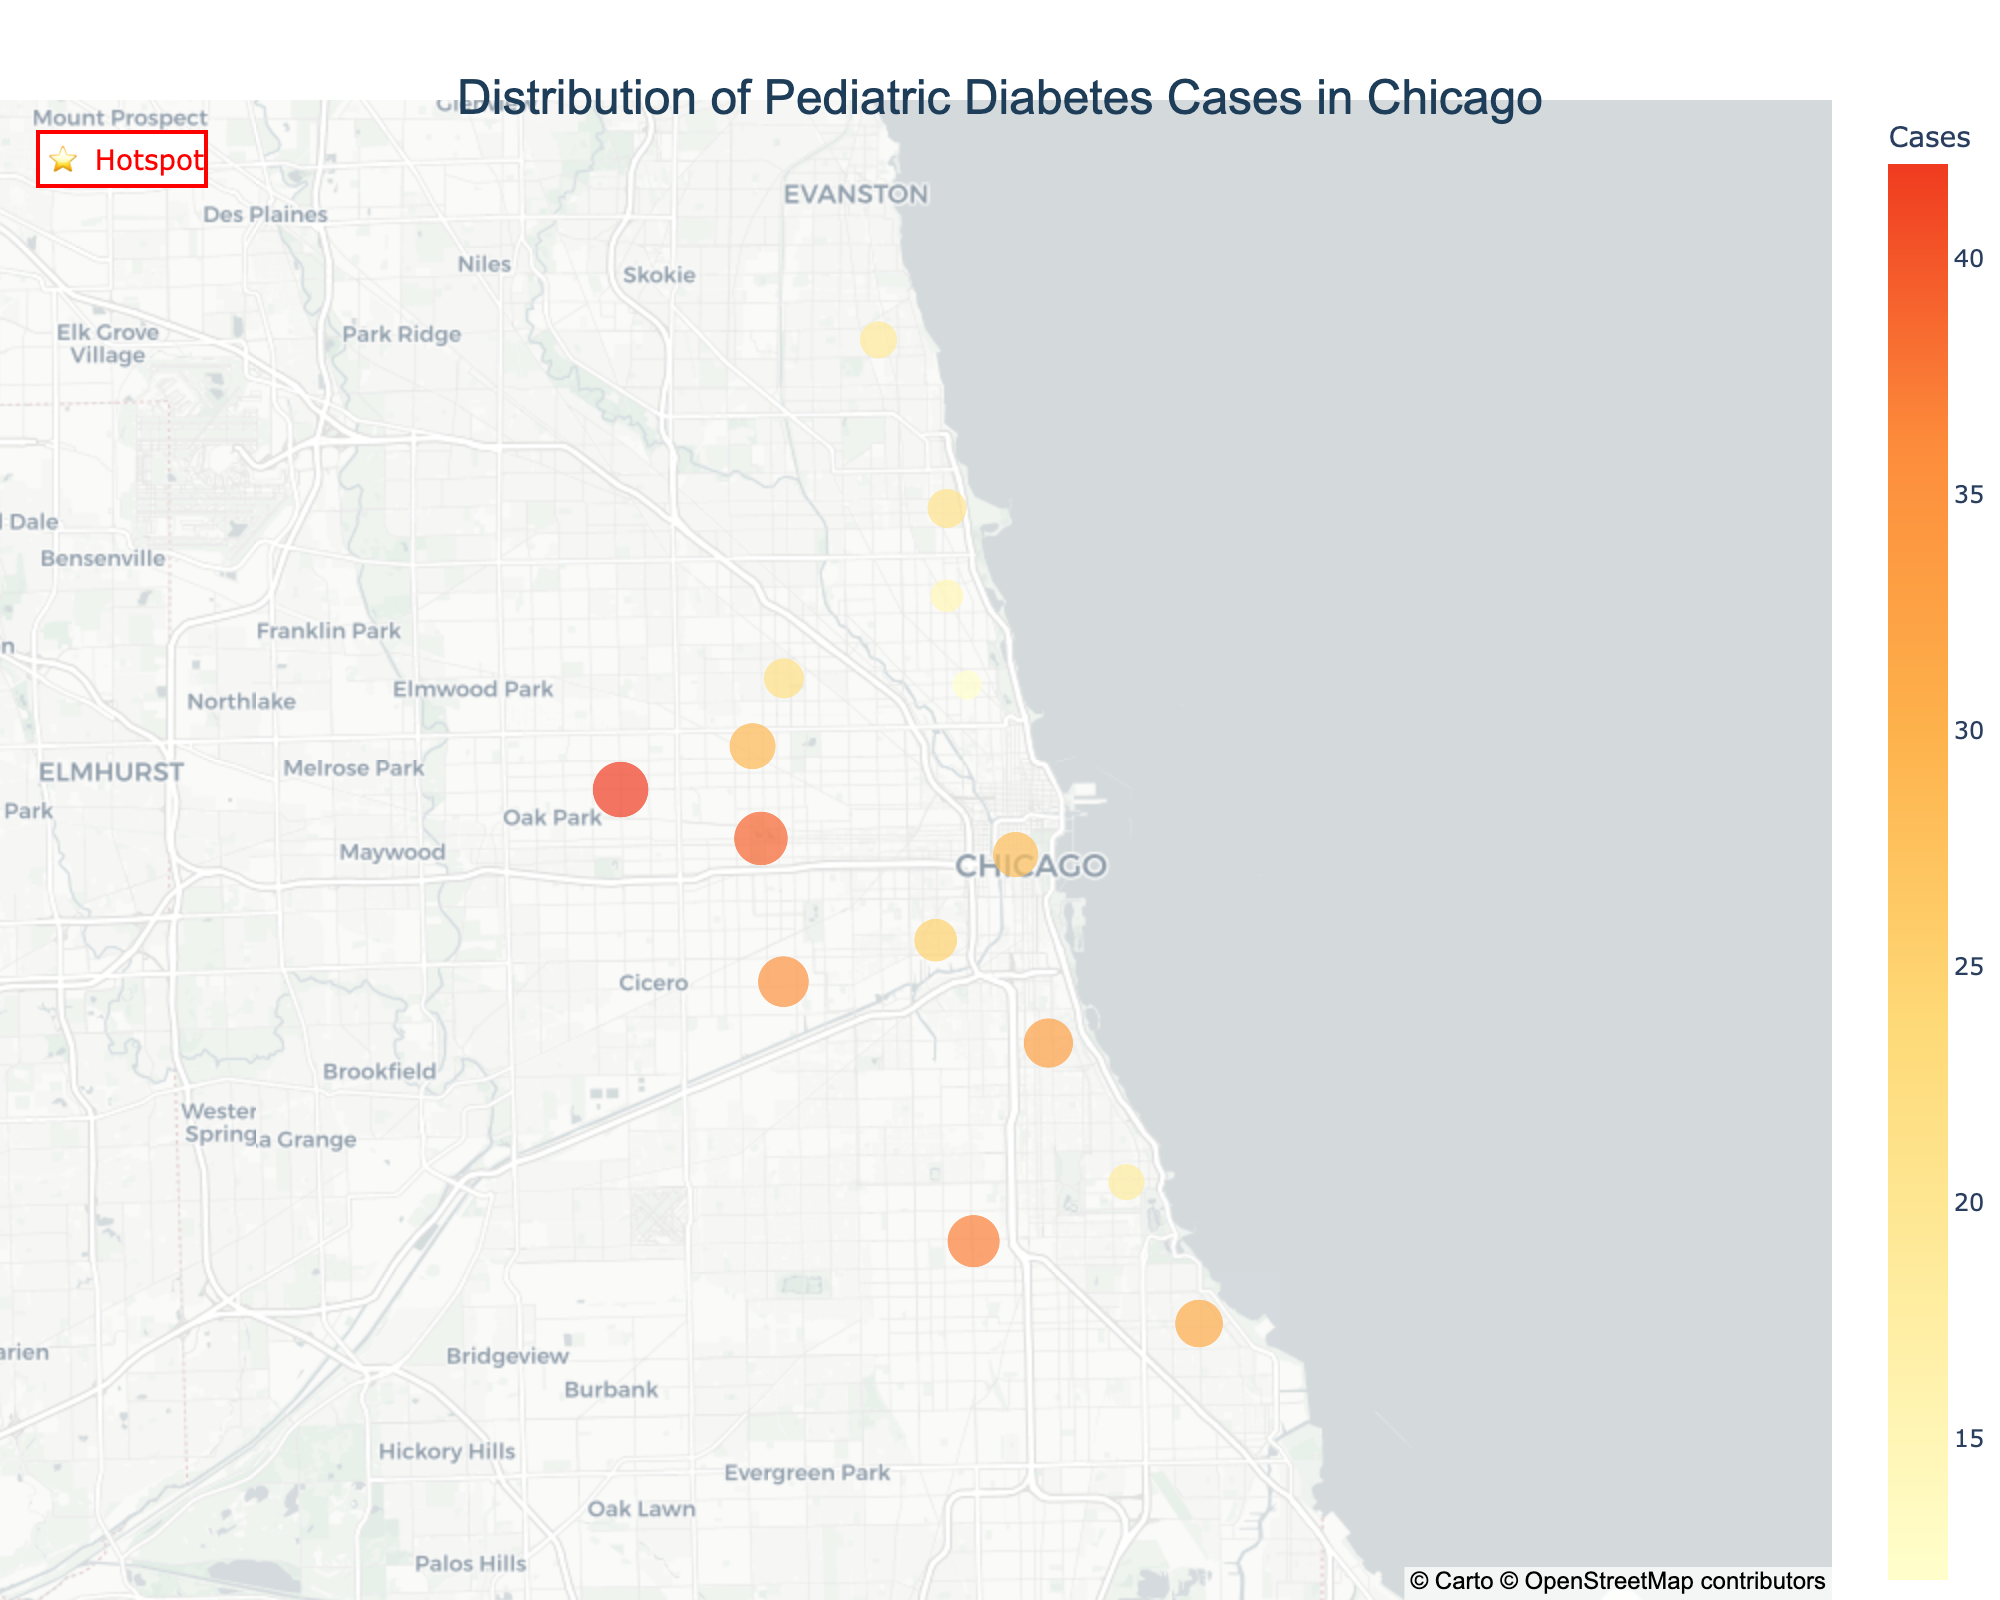Which neighborhood has the highest number of pediatric diabetes cases? By inspecting the plot and looking for the size of the markers representing the number of diabetes cases, Austin has the largest marker indicating the highest number of cases.
Answer: Austin Which hotspots are identified in the plot? Hotspots are highlighted with red star markers. The neighborhoods with such markers are Downtown, Austin, Englewood, South Shore, Bronzeville, Garfield Park, and Little Village.
Answer: Downtown, Austin, Englewood, South Shore, Bronzeville, Garfield Park, Little Village What is the total number of pediatric diabetes cases in the highlighted hotspots? Summing up the number of diabetes cases in hotspots: Downtown (28), Austin (42), Englewood (37), South Shore (31), Bronzeville (33), Garfield Park (39), Little Village (35). Total = 28 + 42 + 37 + 31 + 33 + 39 + 35 = 245.
Answer: 245 What neighborhood with a hotspot has the lowest number of pediatric diabetes cases? By checking the diabetes cases in neighborhoods marked as hotspots, Downtown has the lowest number, which is 28.
Answer: Downtown Which neighborhood has the highest number of pediatric diabetes cases that is not a hotspot? By comparing non-hotspot neighborhoods' diabetes cases, Humboldt Park has the highest number, which is 29.
Answer: Humboldt Park Is there a noticeable geographic clustering of diabetes cases? The plot shows a clustering of large markers (indicating high diabetes cases) with several hotspots marked in the central and southern neighborhoods like Austin, Englewood, South Shore, Bronzeville, Garfield Park, and Little Village, indicating geographic clustering.
Answer: Yes How many neighborhoods have 20 or more pediatric diabetes cases but are not marked as hotspots? The neighborhoods with 20 or more cases that are not hotspots include Rogers Park (19), Logan Square (22), Uptown (21), and Humboldt Park (29). Considering only neighborhoods with 20 or more, there are three: Logan Square, Uptown, and Humboldt Park.
Answer: 3 